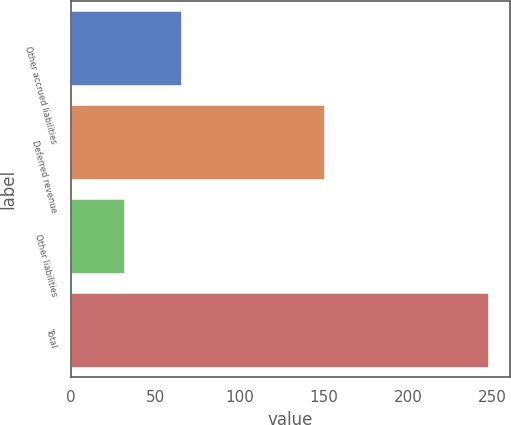<chart> <loc_0><loc_0><loc_500><loc_500><bar_chart><fcel>Other accrued liabilities<fcel>Deferred revenue<fcel>Other liabilities<fcel>Total<nl><fcel>65.7<fcel>150.7<fcel>31.9<fcel>248.3<nl></chart> 